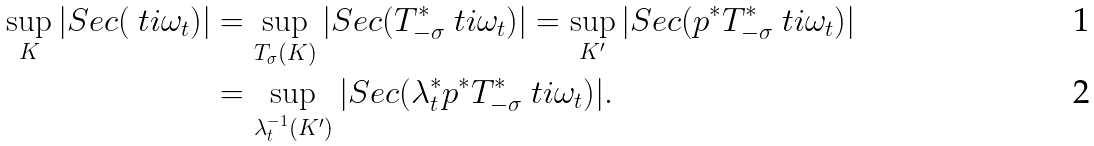<formula> <loc_0><loc_0><loc_500><loc_500>\sup _ { K } | S e c ( \ t i { \omega } _ { t } ) | & = \sup _ { T _ { \sigma } ( K ) } | S e c ( T _ { - \sigma } ^ { * } \ t i { \omega } _ { t } ) | = \sup _ { K ^ { \prime } } | S e c ( p ^ { * } T _ { - \sigma } ^ { * } \ t i { \omega } _ { t } ) | \\ & = \sup _ { \lambda _ { t } ^ { - 1 } ( K ^ { \prime } ) } | S e c ( \lambda _ { t } ^ { * } p ^ { * } T _ { - \sigma } ^ { * } \ t i { \omega } _ { t } ) | .</formula> 